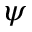<formula> <loc_0><loc_0><loc_500><loc_500>\psi</formula> 